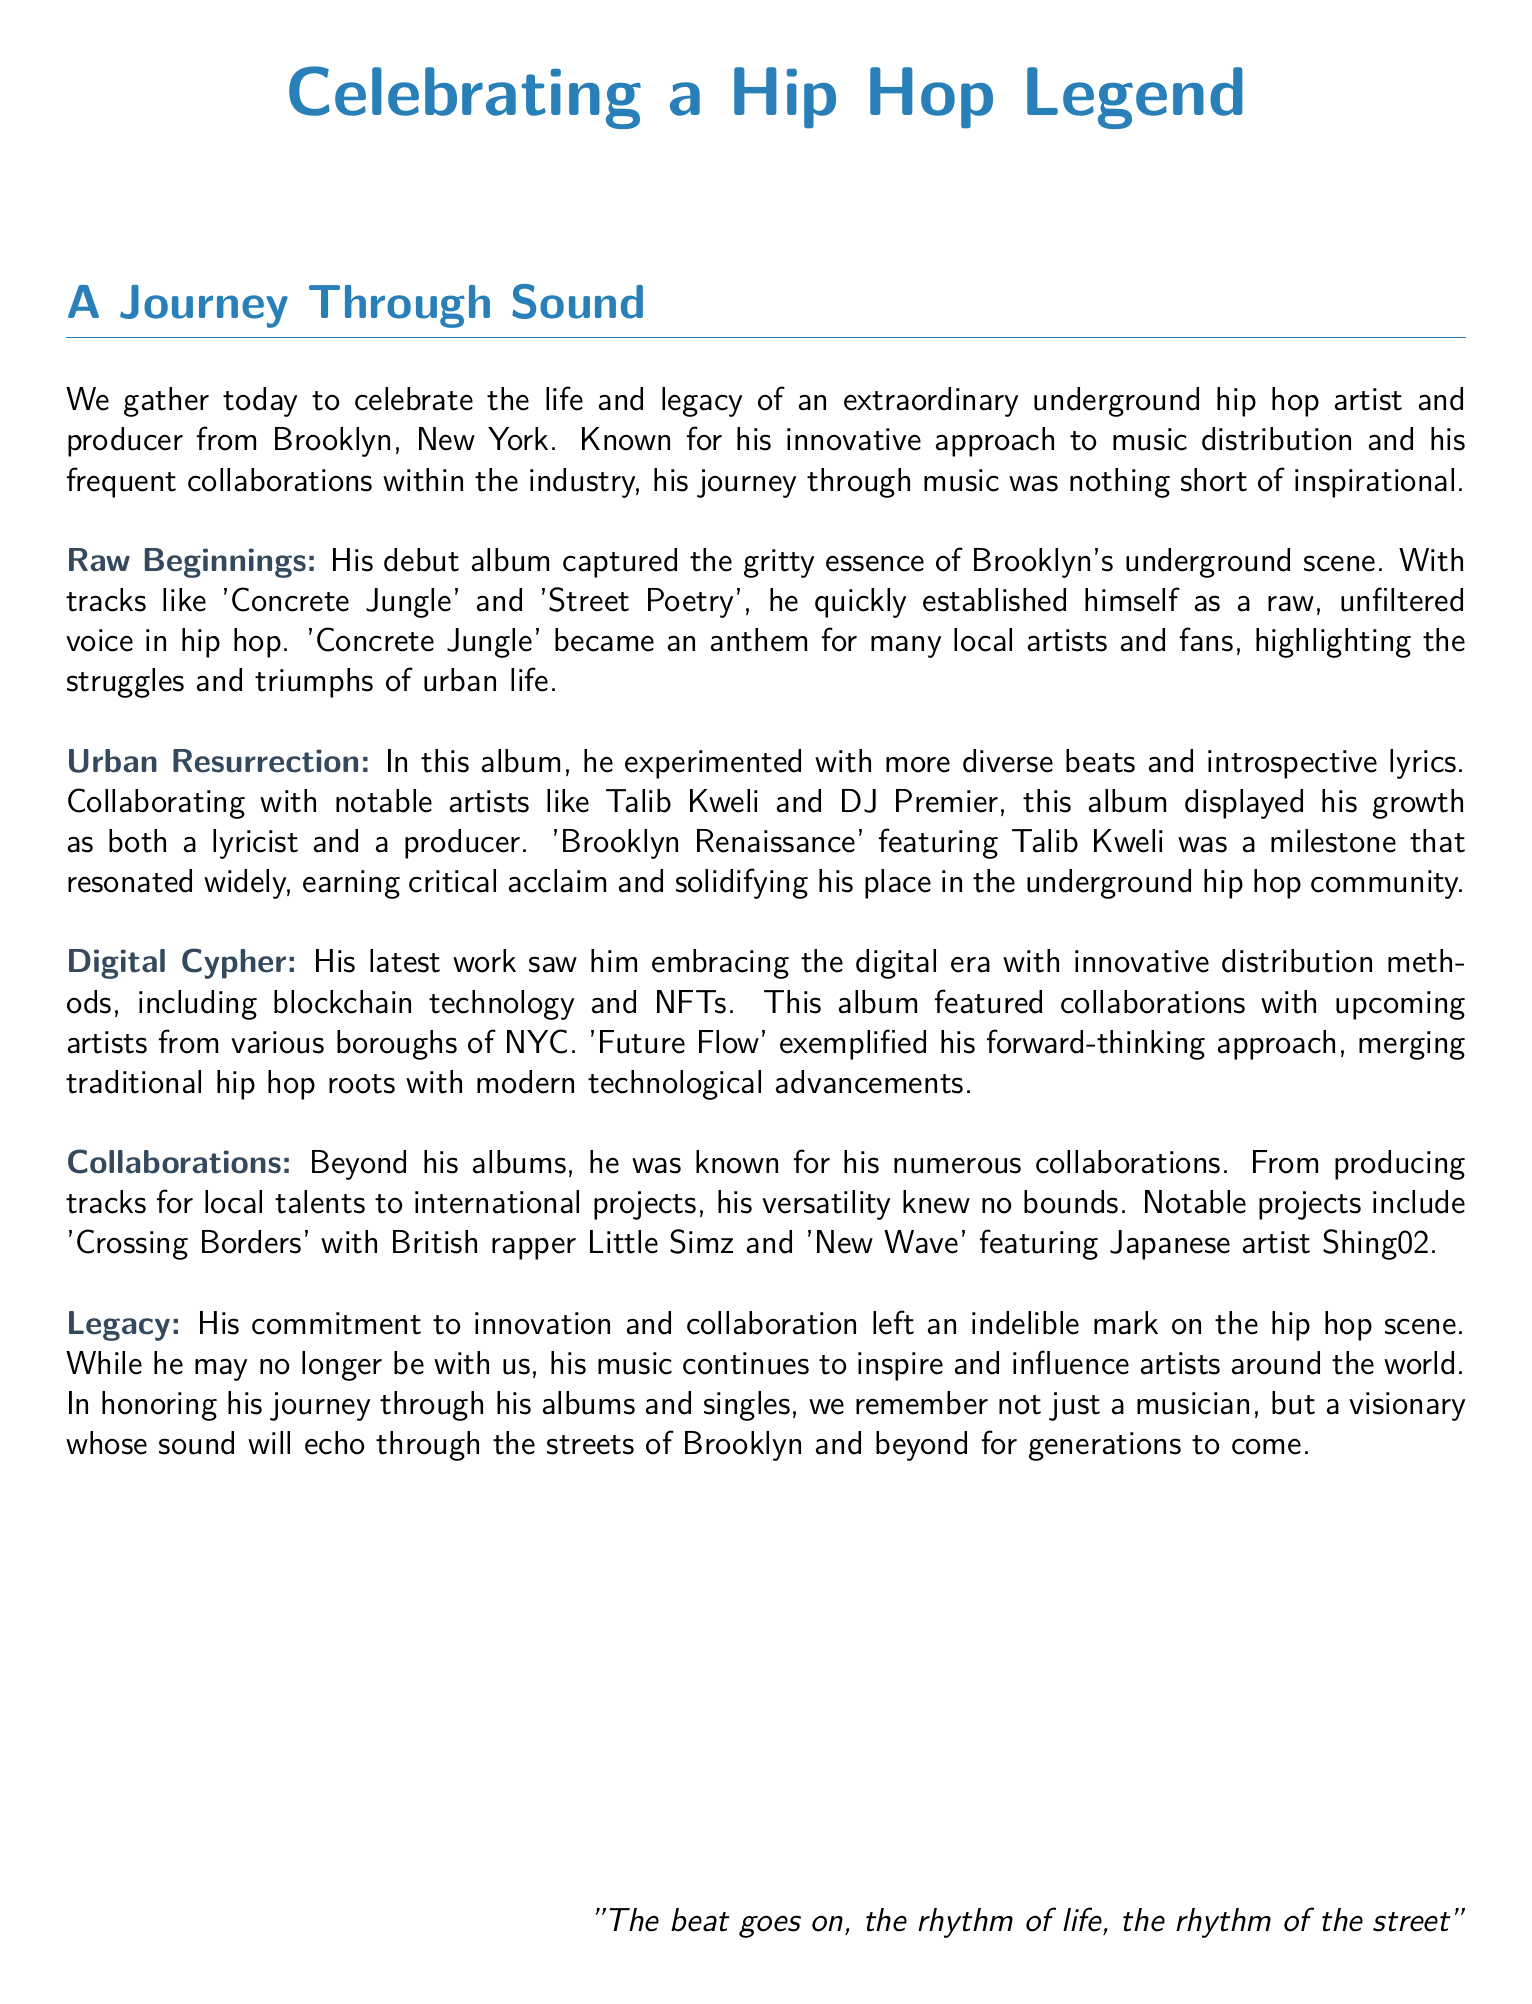What is the title of the document? The title is the main heading that summarizes the document's focus, which is about celebrating a hip hop legend.
Answer: Celebrating a Hip Hop Legend Who collaborated with him on the album 'Brooklyn Renaissance'? The document mentions a notable artist he collaborated with for this album.
Answer: Talib Kweli What is the name of his debut album? This refers to the first album that introduced the artist to the hip hop scene.
Answer: Raw Beginnings Which technology did he embrace in his latest work? The document describes an innovative method he used for music distribution.
Answer: Blockchain technology What anthem became popular among local artists and fans? This is a specific track that captured the essence of urban life and resonated widely.
Answer: Concrete Jungle What phrase summarizes his legacy? This statement reflects his impact and the way he is remembered in the hip hop community.
Answer: A visionary Which two international artists did he collaborate with? These names highlight his versatility and global reach in music collaboration.
Answer: Little Simz and Shing02 What was the theme of the album 'Digital Cypher'? This phrase summarizes the main focus and approach of the album's content.
Answer: Digital era What genre of music is the focus of this document? This indicates the musical style associated with the artist mentioned in the eulogy.
Answer: Hip hop 